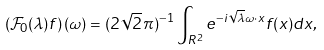<formula> <loc_0><loc_0><loc_500><loc_500>\left ( \mathcal { F } _ { 0 } ( \lambda ) f \right ) ( \omega ) = ( 2 \sqrt { 2 } \, \pi ) ^ { - 1 } \int _ { { R } ^ { 2 } } e ^ { - i { \sqrt { \lambda } } \omega \cdot x } f ( x ) d x ,</formula> 